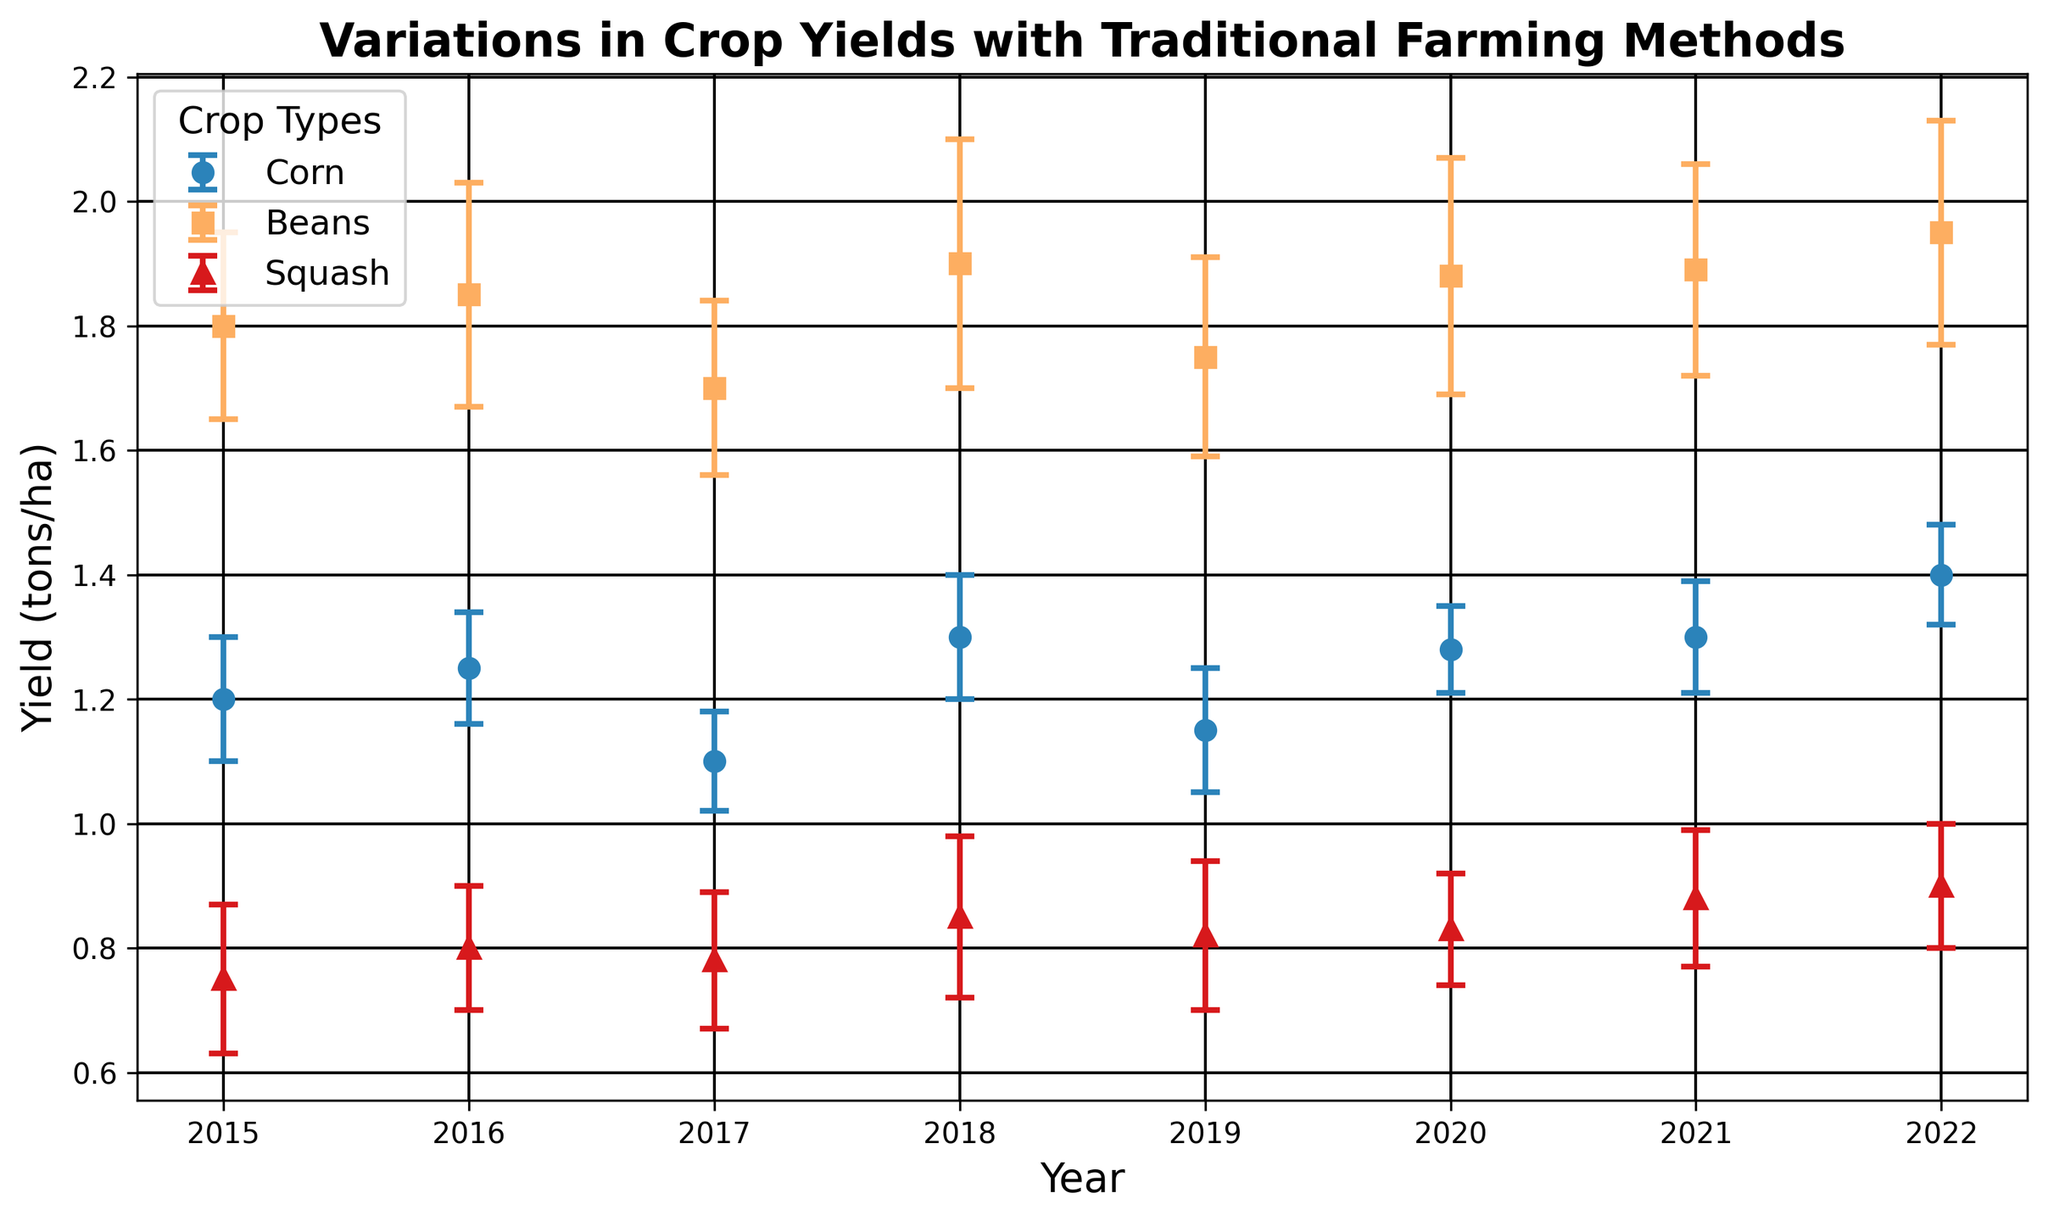What is the overall trend in corn yield from 2015 to 2022? The corn yield shows a general increasing trend from 2015 to 2022. Observing the data points for corn over the years, we see yields start at 1.2 in 2015 and reach 1.4 by 2022, despite minor fluctuations.
Answer: Increasing Which crop had the highest yield in 2022? In 2022, Beans had the highest yield. By comparing the yields of Corn (1.4), Beans (1.95), and Squash (0.9) for that year, Beans had the highest value.
Answer: Beans Which year shows the smallest yield for squash? Squash had the smallest yield in 2015, with a yield of 0.75 tons/ha. Comparing all the years from the chart, 2015 has the lowest value for squash.
Answer: 2015 What is the average corn yield from 2015 to 2022? The corn yields from 2015 to 2022 are as follows: 1.2, 1.25, 1.1, 1.3, 1.15, 1.28, 1.3, 1.4. Summing these values gives a total yield of 10.98, and dividing by 8 (the number of years) gives an average yield of 1.3725.
Answer: 1.3725 In which year did beans yield increase the most compared to the previous year? Comparing the yield differences year by year for beans: 2016 (1.85-1.8=0.05), 2017 (1.7-1.85=-0.15), 2018 (1.9-1.7=0.2), 2019 (1.75-1.9=-0.15), 2020 (1.88-1.75=0.13), 2021 (1.89-1.88=0.01), 2022 (1.95-1.89=0.06). The largest increase is in 2018 with a 0.2 increase.
Answer: 2018 Which crop type has the most consistent yield over the years based on the error margins? Corn has the smallest standard deviations in yields consistently across all years (ranging between 0.07 and 0.1), suggesting it has the most consistent yield compared to Beans and Squash, which have larger variations.
Answer: Corn What is the difference in squash yield between 2015 and 2022? The squash yield in 2015 is 0.75 tons/ha, and in 2022 it is 0.9 tons/ha. The difference is calculated as 0.9 - 0.75 = 0.15 tons/ha.
Answer: 0.15 Which crop type showed the greatest variability in yield across the years? Beans showed the greatest variability in yield with error margins (standard deviations) ranging from 0.14 to 0.2, indicating larger fluctuations in yield across the years when compared to Corn and Squash.
Answer: Beans What was the corn yield and its error margin in 2020? In 2020, the corn yield was 1.28 tons/ha with an error margin of 0.07. This is directly read from the chart for the year 2020.
Answer: 1.28, 0.07 Which year saw the highest overall yield among all crops? In 2022, Beans had the highest yield of 1.95 tons/ha, which is the highest overall yield among all crops across all years.
Answer: 2022 